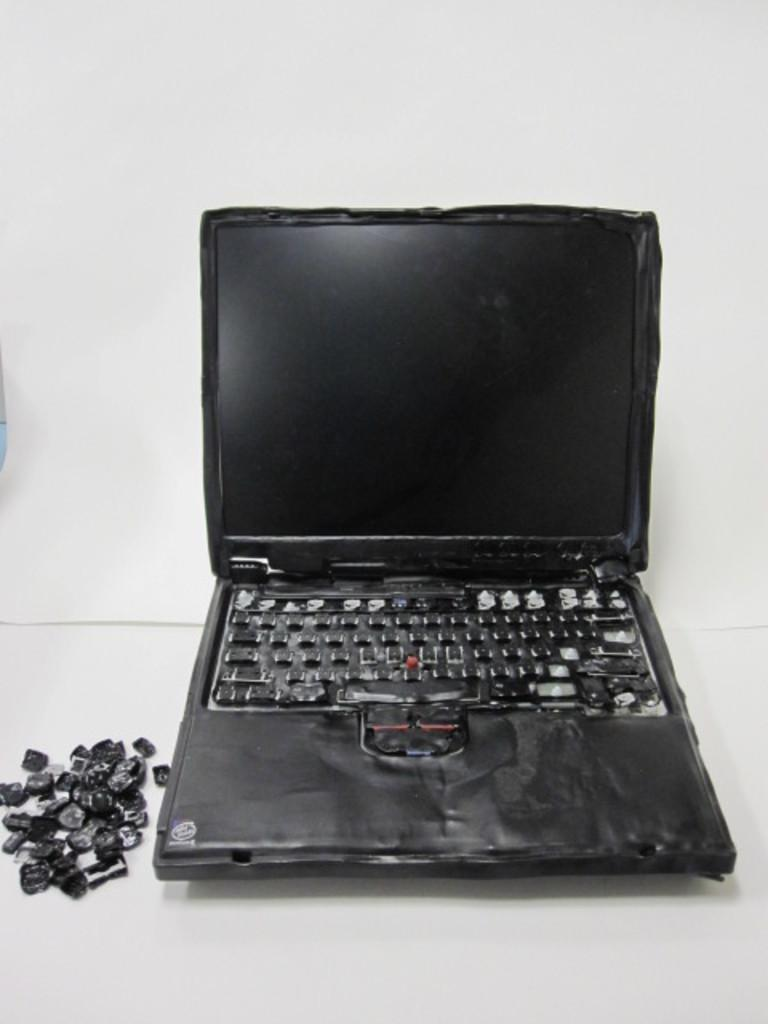What electronic device is present in the image? There is a laptop in the image. What is the color of the background in the image? The laptop is on a white background. What part of the laptop can be seen in the image? There are keys visible in the bottom left of the image. What flavor of soap is being used to clean the laptop in the image? There is no soap present in the image, and the laptop is not being cleaned. 